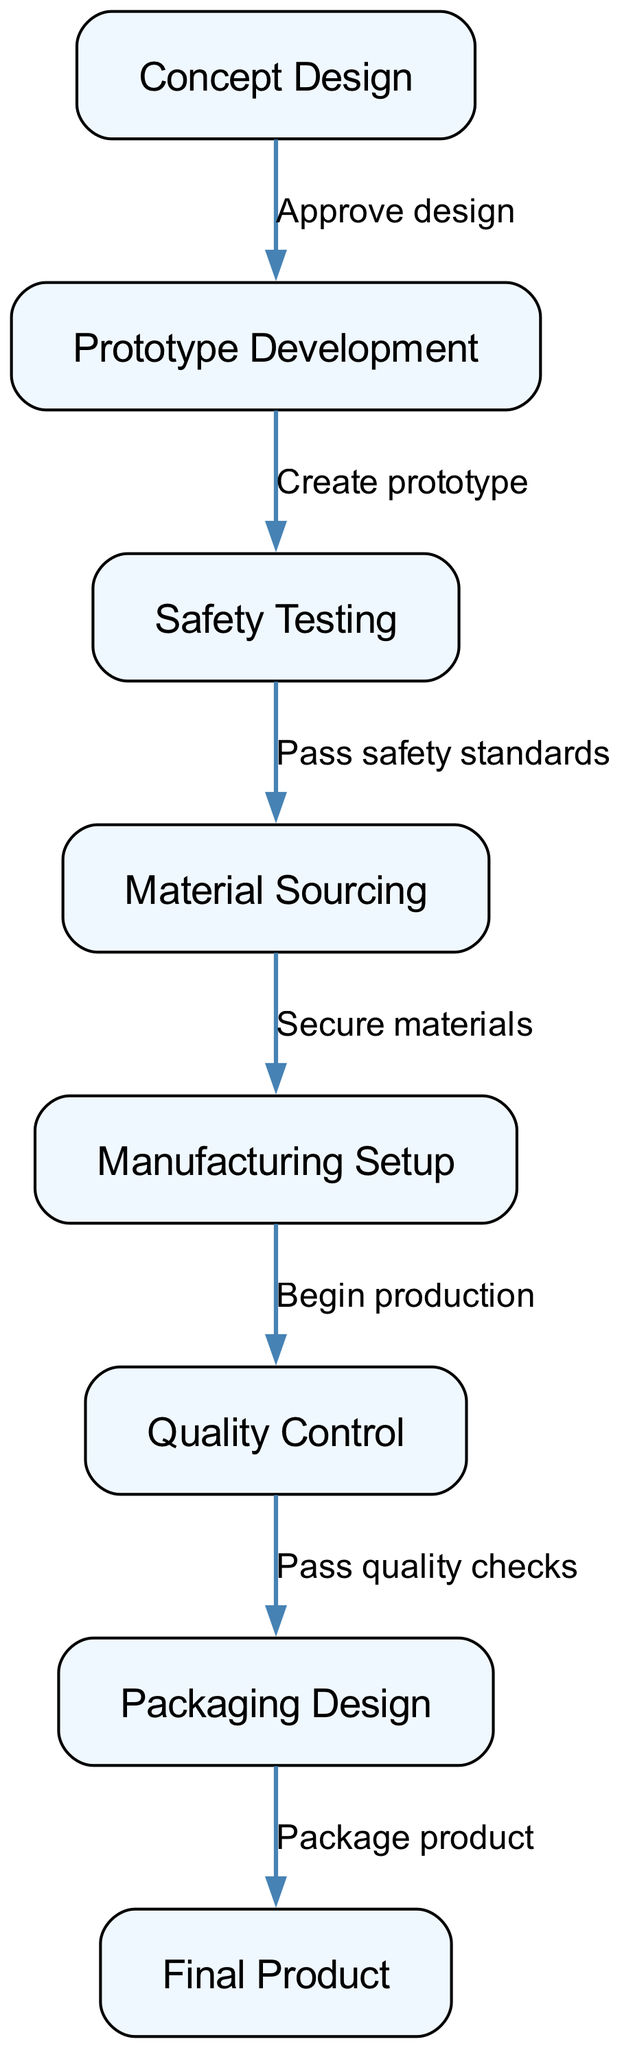What is the endpoint of the flowchart? The endpoint of the flowchart is indicated by the node labeled "Final Product." This is the last step in the production process, showing that all preceding steps lead to this final outcome.
Answer: Final Product How many nodes are present in the diagram? The diagram contains eight nodes, each representing a step in the toy production process. These nodes are shown as distinct rectangles, and counting them leads to the total of eight.
Answer: 8 What is the first step in the toy production process? The first step in the production process is labeled "Concept Design." This node represents the starting point for toy production activities.
Answer: Concept Design What is the action required after "Prototype Development"? The action required after "Prototype Development" is "Safety Testing." According to the flow direction indicated by the edges, this is the next process that follows the development of the prototype.
Answer: Safety Testing What must occur before "Manufacturing Setup"? Before "Manufacturing Setup" can occur, "Material Sourcing" must be completed. The flow of the diagram shows that safety testing must pass successfully to lead to the material sourcing step.
Answer: Material Sourcing What is needed before moving from "Quality Control" to "Packaging Design"? Before moving from "Quality Control" to "Packaging Design," it is required to "Pass quality checks." This step acts as a prerequisite to ensure that the product meets quality standards before packaging.
Answer: Pass quality checks How many edges are there in total? There are seven edges in total, which represent the connections between the nodes in the flowchart. Each edge indicates the relationship or transition from one process to the next.
Answer: 7 What is the relationship between "Safety Testing" and "Material Sourcing"? The relationship between "Safety Testing" and "Material Sourcing" is that "Safety Testing" must "Pass safety standards" before leading to "Material Sourcing." Safety standards serve as a necessary condition for sourcing materials.
Answer: Pass safety standards What is done after packaging design? After "Packaging Design", the final step is to reach the "Final Product." Packaging wraps up all processes, culminating in the completed toy ready for distribution.
Answer: Final Product 